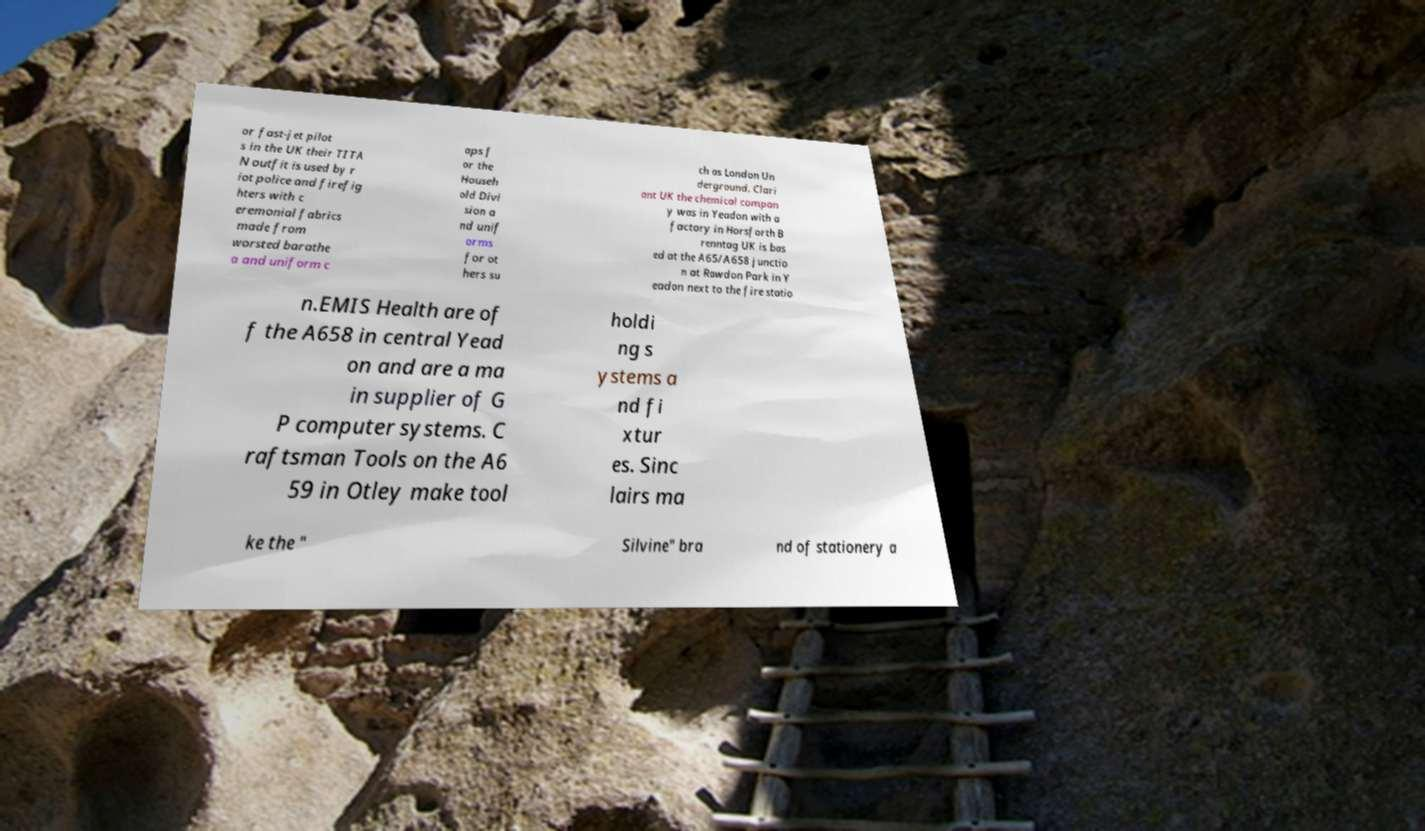I need the written content from this picture converted into text. Can you do that? or fast-jet pilot s in the UK their TITA N outfit is used by r iot police and firefig hters with c eremonial fabrics made from worsted barathe a and uniform c aps f or the Househ old Divi sion a nd unif orms for ot hers su ch as London Un derground. Clari ant UK the chemical compan y was in Yeadon with a factory in Horsforth B renntag UK is bas ed at the A65/A658 junctio n at Rawdon Park in Y eadon next to the fire statio n.EMIS Health are of f the A658 in central Yead on and are a ma in supplier of G P computer systems. C raftsman Tools on the A6 59 in Otley make tool holdi ng s ystems a nd fi xtur es. Sinc lairs ma ke the " Silvine" bra nd of stationery a 